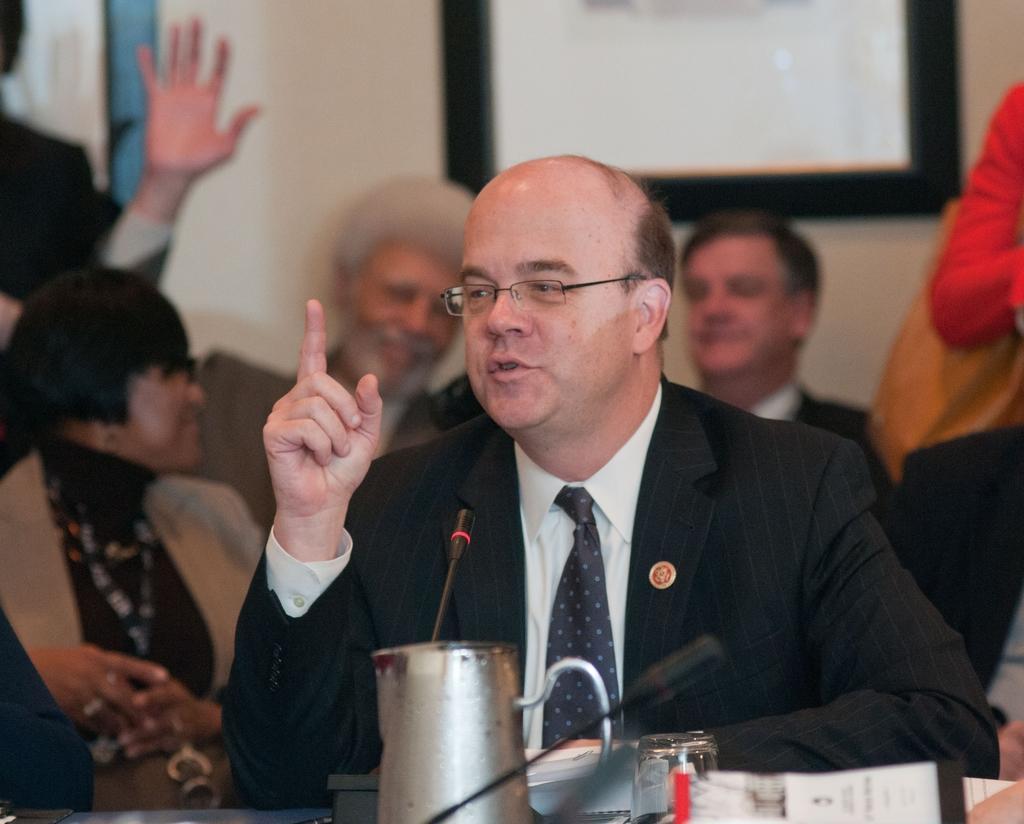Please provide a concise description of this image. In this image there is a person sitting. Before him there is a table having a jar, mike's, papers and few objects. Behind him there are people. A frame is attached to the wall. 